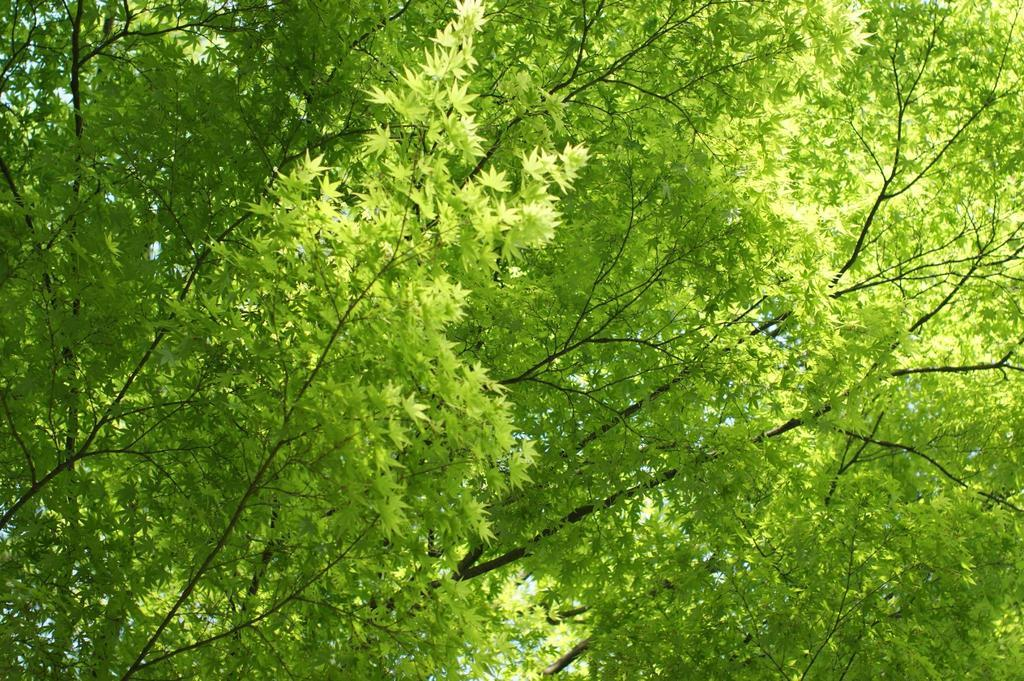What type of vegetation can be seen in the image? There are trees in the image. What is the color of the leaves on the trees? The trees have green leaves. What can be seen in the background of the image? The sky is visible in the background of the image. What is the weight of the cent in the image? There is no cent present in the image, so it is not possible to determine its weight. 